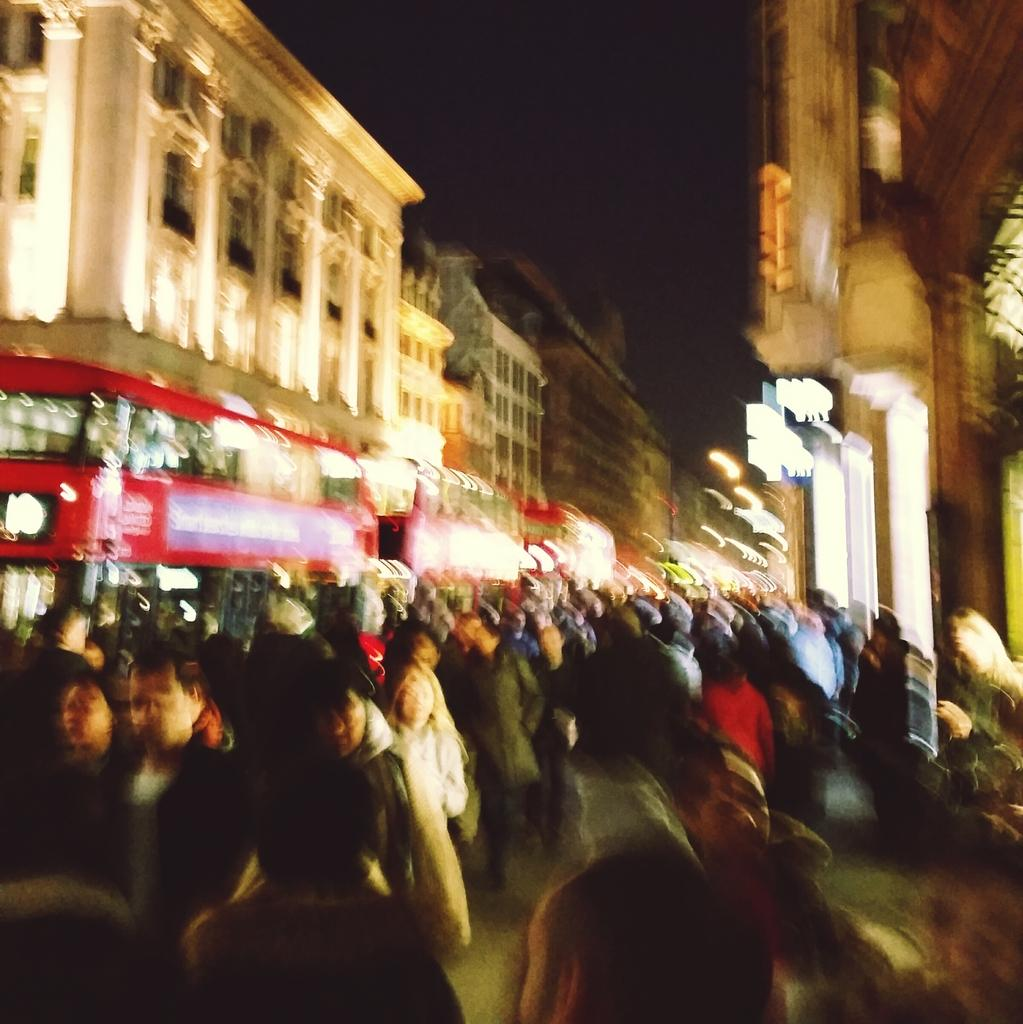What is the overall quality of the image? The image is blurred. Can you identify any subjects in the image? Yes, there are people in the image. What can be seen in the background of the image? There are buildings in the background of the image. What type of illumination is present in the image? There are lights visible in the image. What can be inferred about the environment in which the image was taken? The image appears to be taken in a dark environment. What type of cup can be seen in the image? There is no cup present in the image. What is the smell of the baby in the image? There is no baby present in the image, so it is not possible to determine the smell. 